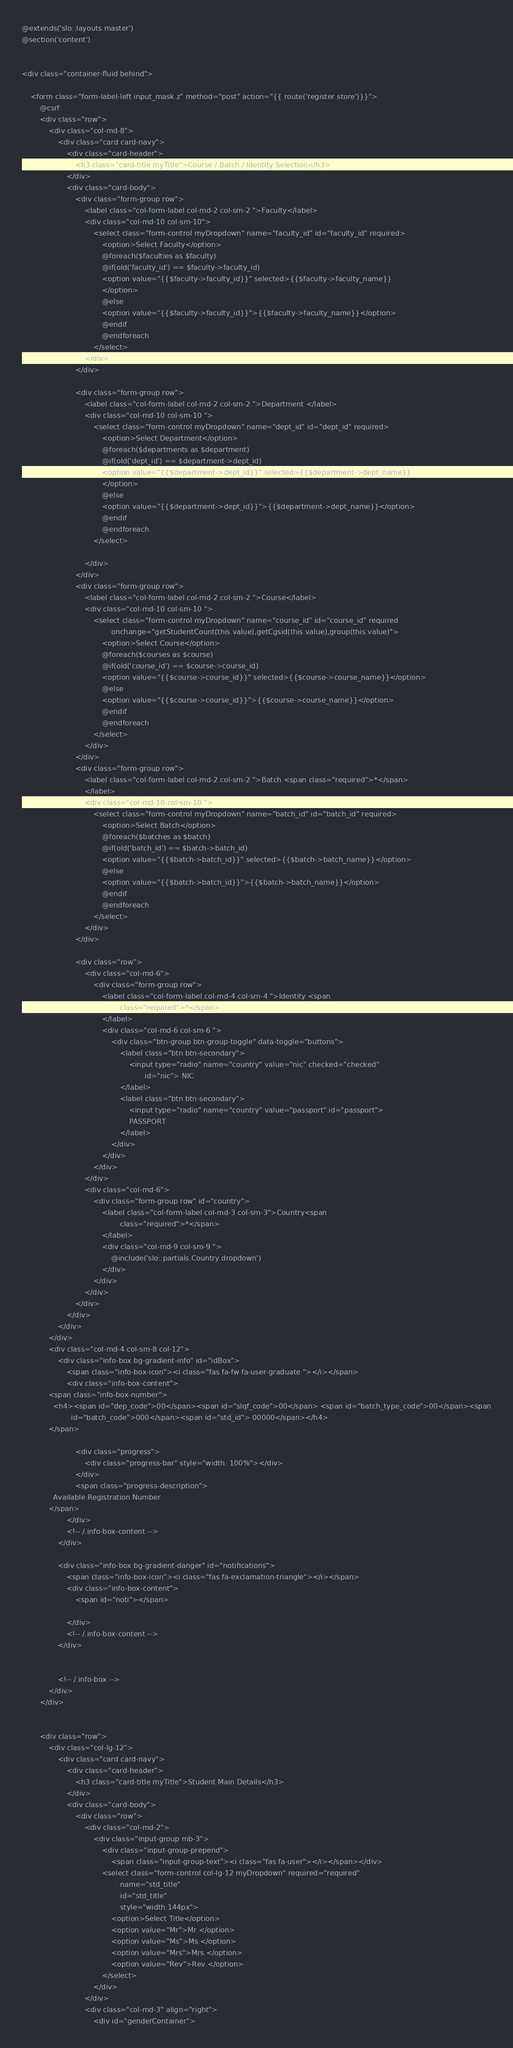Convert code to text. <code><loc_0><loc_0><loc_500><loc_500><_PHP_>@extends('slo::layouts.master')
@section('content')


<div class="container-fluid behind">

    <form class="form-label-left input_mask z" method="post" action="{{ route('register.store')}}">
        @csrf
        <div class="row">
            <div class="col-md-8">
                <div class="card card-navy">
                    <div class="card-header">
                        <h3 class="card-title myTitle">Course / Batch / Identity Selection</h3>
                    </div>
                    <div class="card-body">
                        <div class="form-group row">
                            <label class="col-form-label col-md-2 col-sm-2 ">Faculty</label>
                            <div class="col-md-10 col-sm-10">
                                <select class="form-control myDropdown" name="faculty_id" id="faculty_id" required>
                                    <option>Select Faculty</option>
                                    @foreach($faculties as $faculty)
                                    @if(old('faculty_id') == $faculty->faculty_id)
                                    <option value="{{$faculty->faculty_id}}" selected>{{$faculty->faculty_name}}
                                    </option>
                                    @else
                                    <option value="{{$faculty->faculty_id}}">{{$faculty->faculty_name}}</option>
                                    @endif
                                    @endforeach
                                </select>
                            </div>
                        </div>

                        <div class="form-group row">
                            <label class="col-form-label col-md-2 col-sm-2 ">Department </label>
                            <div class="col-md-10 col-sm-10 ">
                                <select class="form-control myDropdown" name="dept_id" id="dept_id" required>
                                    <option>Select Department</option>
                                    @foreach($departments as $department)
                                    @if(old('dept_id') == $department->dept_id)
                                    <option value="{{$department->dept_id}}" selected>{{$department->dept_name}}
                                    </option>
                                    @else
                                    <option value="{{$department->dept_id}}">{{$department->dept_name}}</option>
                                    @endif
                                    @endforeach
                                </select>

                            </div>
                        </div>
                        <div class="form-group row">
                            <label class="col-form-label col-md-2 col-sm-2 ">Course</label>
                            <div class="col-md-10 col-sm-10 ">
                                <select class="form-control myDropdown" name="course_id" id="course_id" required
                                        onchange="getStudentCount(this.value),getCgsid(this.value),group(this.value)">
                                    <option>Select Course</option>
                                    @foreach($courses as $course)
                                    @if(old('course_id') == $course->course_id)
                                    <option value="{{$course->course_id}}" selected>{{$course->course_name}}</option>
                                    @else
                                    <option value="{{$course->course_id}}">{{$course->course_name}}</option>
                                    @endif
                                    @endforeach
                                </select>
                            </div>
                        </div>
                        <div class="form-group row">
                            <label class="col-form-label col-md-2 col-sm-2 ">Batch <span class="required">*</span>
                            </label>
                            <div class="col-md-10 col-sm-10 ">
                                <select class="form-control myDropdown" name="batch_id" id="batch_id" required>
                                    <option>Select Batch</option>
                                    @foreach($batches as $batch)
                                    @if(old('batch_id') == $batch->batch_id)
                                    <option value="{{$batch->batch_id}}" selected>{{$batch->batch_name}}</option>
                                    @else
                                    <option value="{{$batch->batch_id}}">{{$batch->batch_name}}</option>
                                    @endif
                                    @endforeach
                                </select>
                            </div>
                        </div>

                        <div class="row">
                            <div class="col-md-6">
                                <div class="form-group row">
                                    <label class="col-form-label col-md-4 col-sm-4 ">Identity <span
                                            class="required">*</span>
                                    </label>
                                    <div class="col-md-6 col-sm-6 ">
                                        <div class="btn-group btn-group-toggle" data-toggle="buttons">
                                            <label class="btn btn-secondary">
                                                <input type="radio" name="country" value="nic" checked="checked"
                                                       id="nic"> NIC
                                            </label>
                                            <label class="btn btn-secondary">
                                                <input type="radio" name="country" value="passport" id="passport">
                                                PASSPORT
                                            </label>
                                        </div>
                                    </div>
                                </div>
                            </div>
                            <div class="col-md-6">
                                <div class="form-group row" id="country">
                                    <label class="col-form-label col-md-3 col-sm-3">Country<span
                                            class="required">*</span>
                                    </label>
                                    <div class="col-md-9 col-sm-9 ">
                                        @include('slo::partials.Country.dropdown')
                                    </div>
                                </div>
                            </div>
                        </div>
                    </div>
                </div>
            </div>
            <div class="col-md-4 col-sm-8 col-12">
                <div class="info-box bg-gradient-info" id="idBox">
                    <span class="info-box-icon"><i class="fas fa-fw fa-user-graduate "></i></span>
                    <div class="info-box-content">
            <span class="info-box-number">
              <h4><span id="dep_code">00</span><span id="slqf_code">00</span> <span id="batch_type_code">00</span><span
                      id="batch_code">000</span><span id="std_id"> 00000</span></h4>
            </span>

                        <div class="progress">
                            <div class="progress-bar" style="width: 100%"></div>
                        </div>
                        <span class="progress-description">
              Available Registration Number
            </span>
                    </div>
                    <!-- /.info-box-content -->
                </div>

                <div class="info-box bg-gradient-danger" id="notifications">
                    <span class="info-box-icon"><i class="fas fa-exclamation-triangle"></i></span>
                    <div class="info-box-content">
                        <span id="noti"></span>

                    </div>
                    <!-- /.info-box-content -->
                </div>


                <!-- /.info-box -->
            </div>
        </div>


        <div class="row">
            <div class="col-lg-12">
                <div class="card card-navy">
                    <div class="card-header">
                        <h3 class="card-title myTitle">Student Main Details</h3>
                    </div>
                    <div class="card-body">
                        <div class="row">
                            <div class="col-md-2">
                                <div class="input-group mb-3">
                                    <div class="input-group-prepend">
                                        <span class="input-group-text"><i class="fas fa-user"></i></span></div>
                                    <select class="form-control col-lg-12 myDropdown" required="required"
                                            name="std_title"
                                            id="std_title"
                                            style="width:144px">
                                        <option>Select Title</option>
                                        <option value="Mr">Mr.</option>
                                        <option value="Ms">Ms.</option>
                                        <option value="Mrs">Mrs.</option>
                                        <option value="Rev">Rev.</option>
                                    </select>
                                </div>
                            </div>
                            <div class="col-md-3" align="right">
                                <div id="genderContainer"></code> 